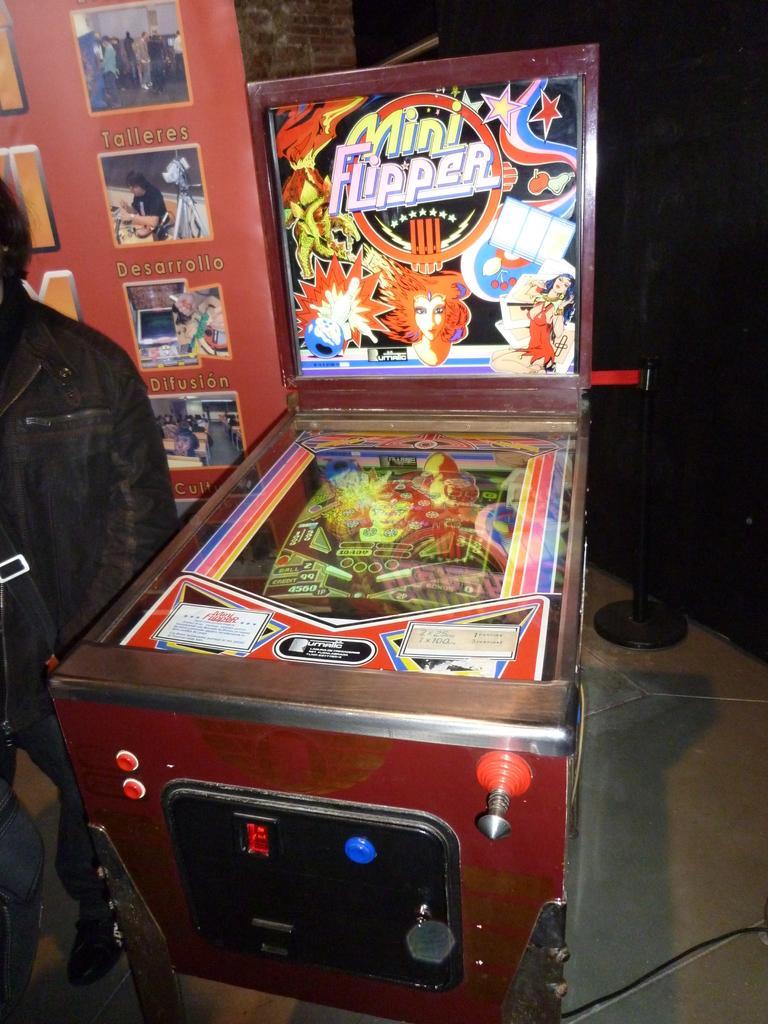Can you describe this image briefly? In this picture I can see a pinball machine, there is a person standing, and in the background there is a board and a stanchion barrier. 